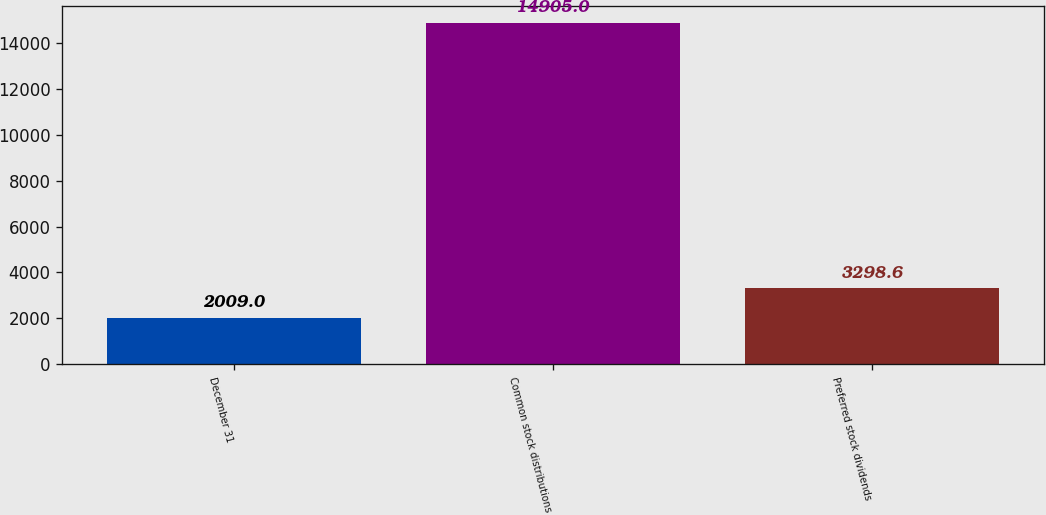Convert chart. <chart><loc_0><loc_0><loc_500><loc_500><bar_chart><fcel>December 31<fcel>Common stock distributions<fcel>Preferred stock dividends<nl><fcel>2009<fcel>14905<fcel>3298.6<nl></chart> 